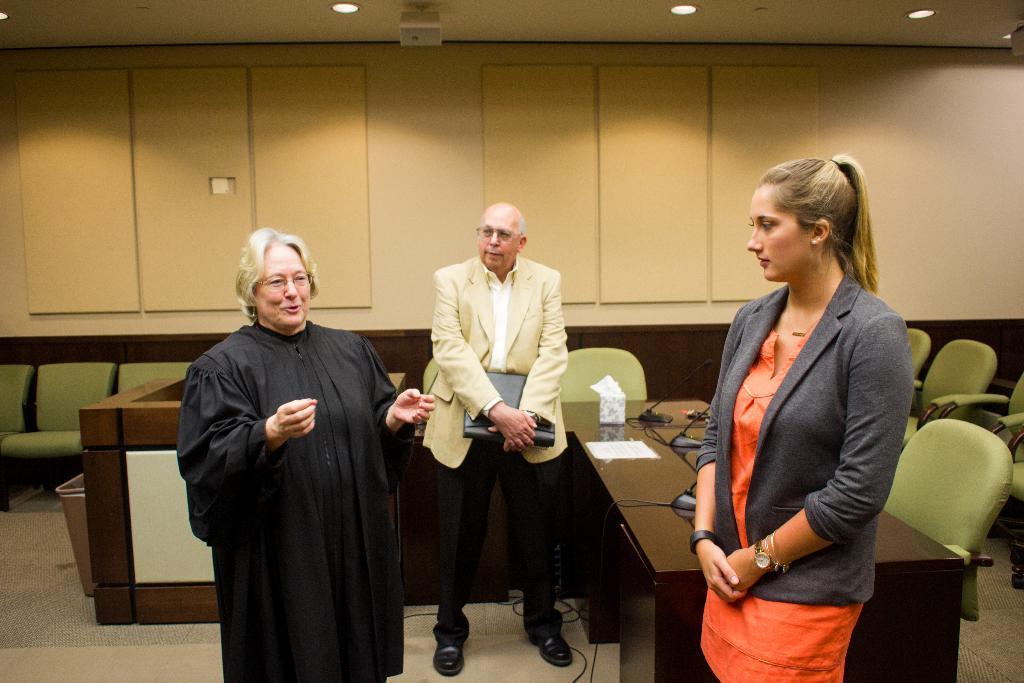Describe this image in one or two sentences. On the left side, there is a person in a black color dress, standing and speaking. On the right side, there is a woman in a gray color jacket, standing. In the background, there are chairs and tables arranged, there is a person holding a file, standing and listening, there are lights attached to the roof and there is a wall. 